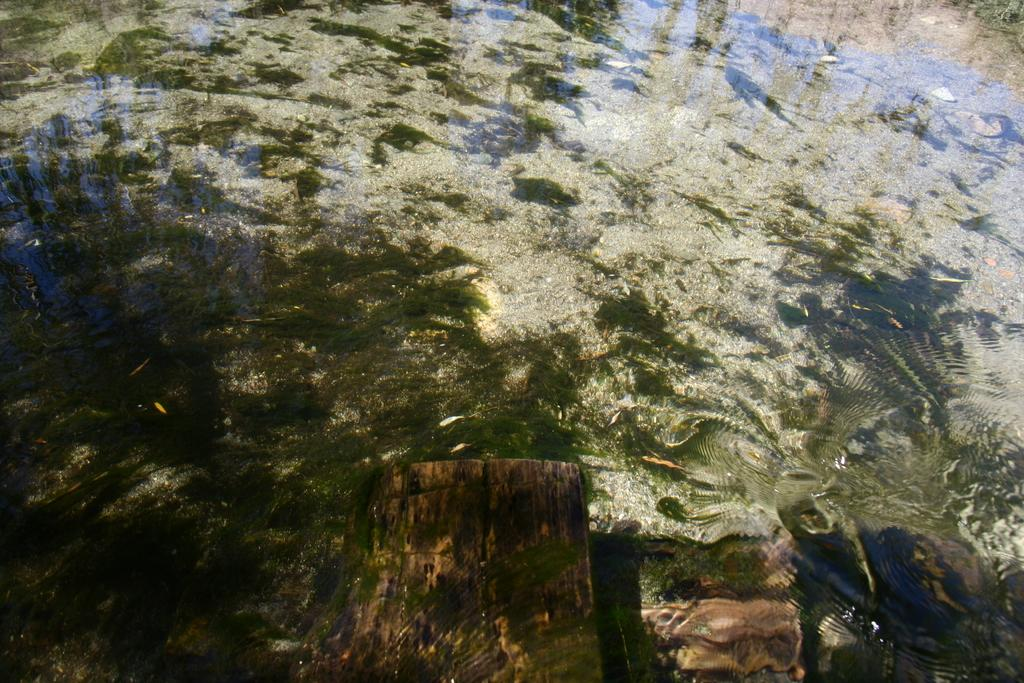What is visible in the image? There is water visible in the image. What type of breakfast is being served in the image? There is no breakfast present in the image; it only features water. What kind of spark can be seen in the image? There is no spark present in the image; it only features water. 